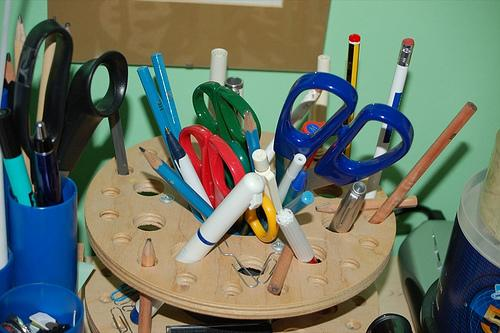Can you tell me how many pencils are included in this image? There are six pencils in the image. How many pairs of scissors with colored handles are there and what are the colors of their handles? There are three pairs of scissors with colored handles - blue, red, and green. Describe the wall in the background, including its color. The wall behind the stationary supplies is sea foam green. How many objects are being held by the wooden holder? The wooden holder contains at least 16 objects, such as pens, pencils, and scissors. Examine the object interaction in the image and explain how the stationary supplies are arranged. The stationary supplies are arranged in a caddy with multiple compartments, keeping similar items together and easily accessible. Comment on the quality of the image in terms of clarity and focus. The image quality is overall clear and focused, with all objects visibly recognizable and distinct. Explain what the object with a wooden pencil, a blue paper clip, and a white plastic top of a marker is. The object is a caddy holding various stationary supplies, like pencils, paper clips, and markers. What color are the handles of the large pair of scissors in the image? The handles of the large pair of scissors are black. Analyze the sentiment of the image by describing the overall mood it conveys. The image portrays a well-organized, clean, and efficient workspace, creating a peaceful and orderly mood. Perform a complex reasoning task by predicting what might happen if the caddy holding the stationary supplies were to suddenly fall over. If the caddy were to fall over, the stationary supplies would likely be scattered on the ground, making the workspace disorganized and potentially causing damage to some items. Describe the position of the sharpened blue pencil. In the wooden holder, next to a red-handle pair of scissors Which items in the holder are unsharpened? A brown wooden pencil List the colors of scissor handles in the image. Blue, red, and green Describe the holder containing pens, pencils, and scissors. It's a perforated wooden holder with holes to hold items and a blue container within it. Describe the case for holding blank CDs. It's in the right middle section of the wooden holder. How many pairs of scissors are in the caddy? Three Can you spot any items in the image that involve writing or drawing? Pens and pencils What color is the wall behind the stationary supplies? Sea foam green What types of items are found in the wooden holder? Pens, pencils, scissors, paper clips, and a case for blank CDs Identify the object located in the lower-left corner of the image. A blue cup containing scissors, pens, and pencils What message does the whiteboard on the right side of the stationary supplies convey? No, it's not mentioned in the image. Point out the similarities between this pen and that pen. Both are in the wooden holder and have different handle colors. Explain the state of the paper clip that's been pulled out of shape. It appears bent and no longer maintains its original shape. Select the color that doesn't match any pencil handle in the image. B) Blue Which objects have a sharpened point? Pencils What type of stationary item is pulled out of shape? A paper clip What is the color of the cup for small odds and ends? Blue Spot the location of the silver colored paper clip. Near the bent paper clip and below the green-handled scissors Label the objects in the blue container. Scissors, pencils, and pens What color is the plastic top of a marker? White 